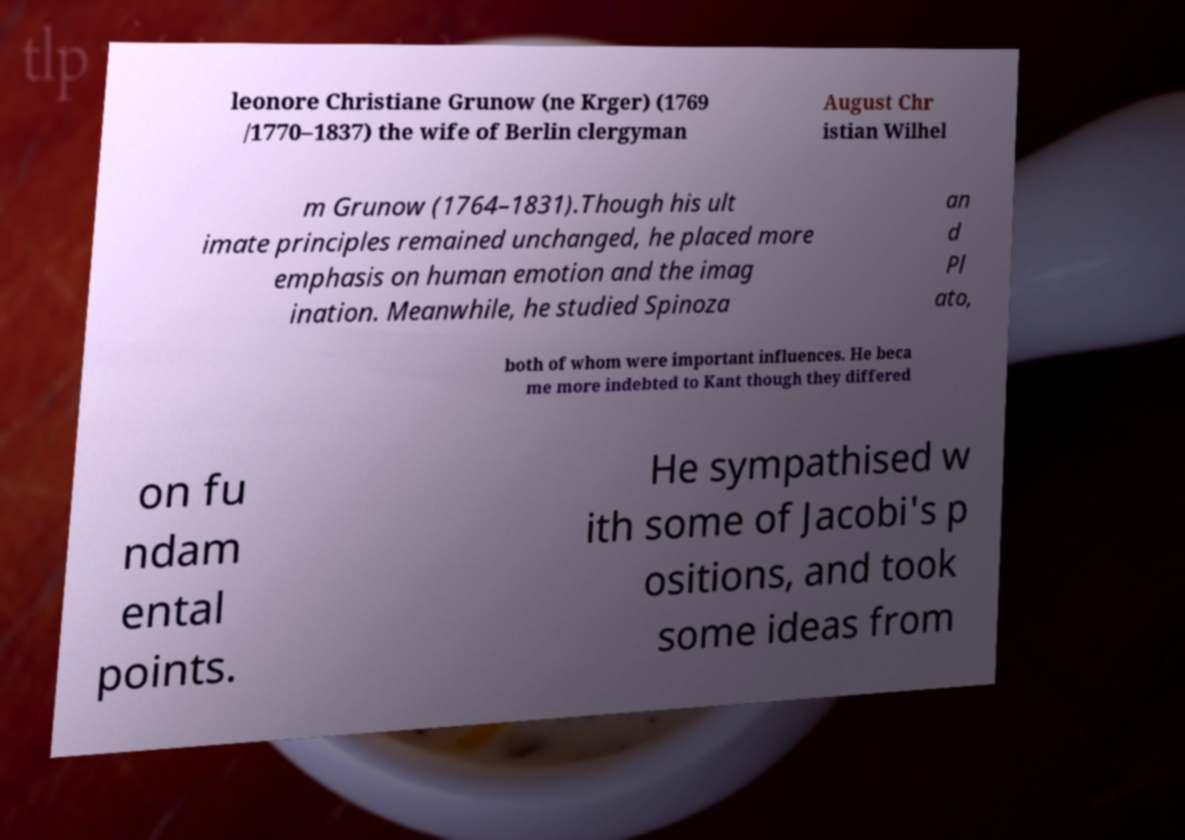Can you read and provide the text displayed in the image?This photo seems to have some interesting text. Can you extract and type it out for me? leonore Christiane Grunow (ne Krger) (1769 /1770–1837) the wife of Berlin clergyman August Chr istian Wilhel m Grunow (1764–1831).Though his ult imate principles remained unchanged, he placed more emphasis on human emotion and the imag ination. Meanwhile, he studied Spinoza an d Pl ato, both of whom were important influences. He beca me more indebted to Kant though they differed on fu ndam ental points. He sympathised w ith some of Jacobi's p ositions, and took some ideas from 